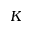<formula> <loc_0><loc_0><loc_500><loc_500>K</formula> 